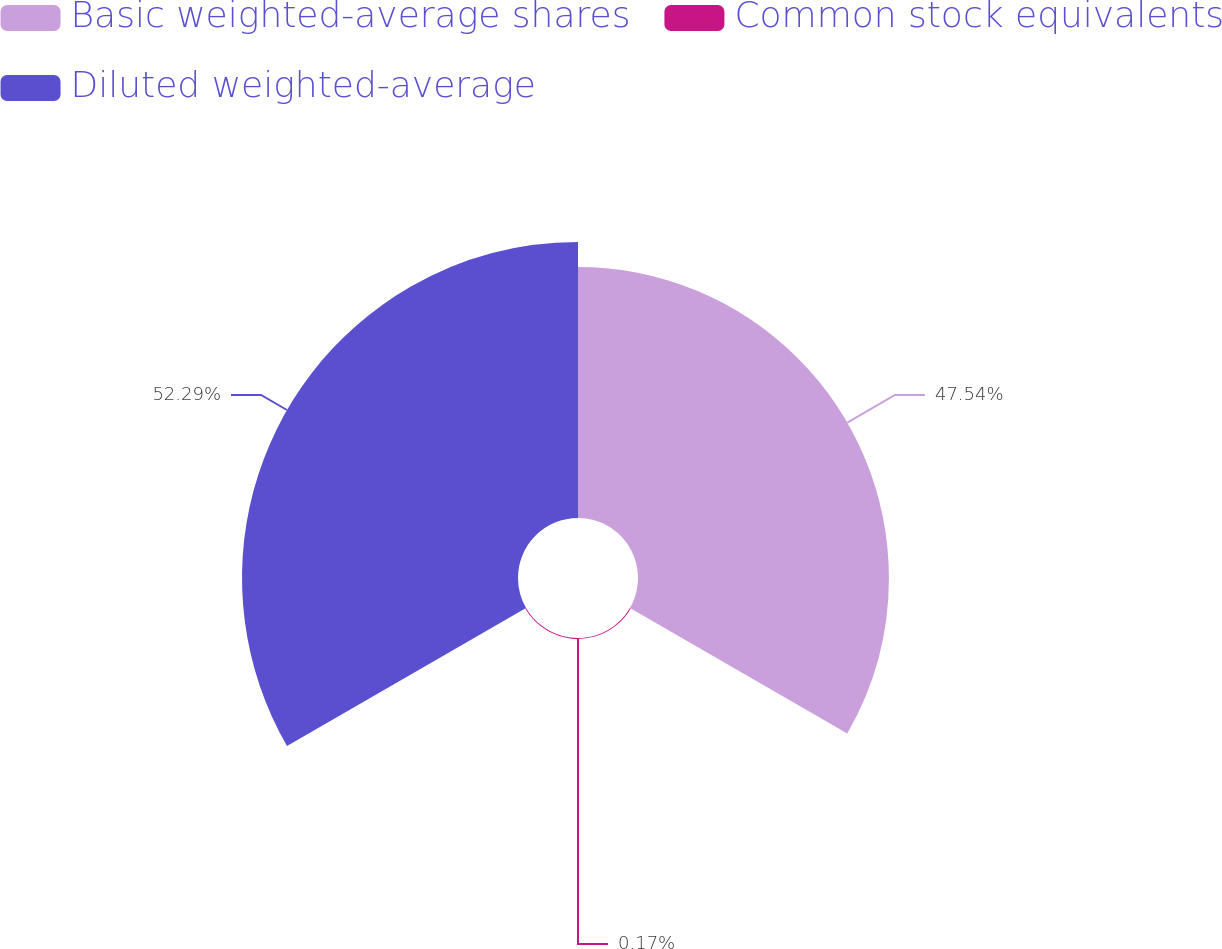<chart> <loc_0><loc_0><loc_500><loc_500><pie_chart><fcel>Basic weighted-average shares<fcel>Common stock equivalents<fcel>Diluted weighted-average<nl><fcel>47.54%<fcel>0.17%<fcel>52.29%<nl></chart> 